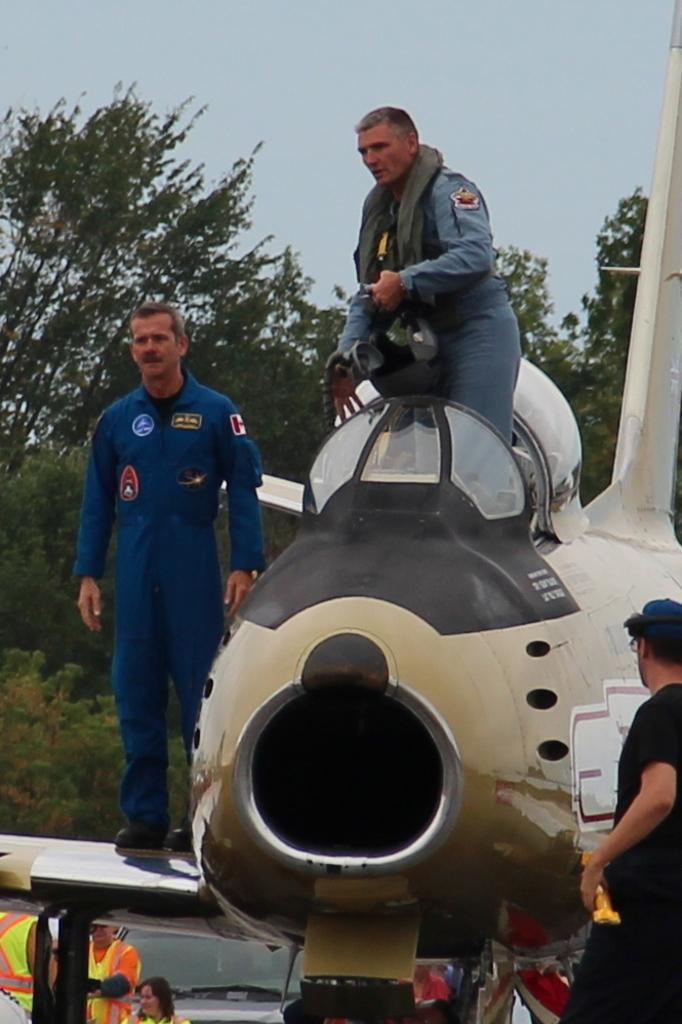What is the main subject of the image? The main subject of the image is an airplane. What are the people in the image doing? The people are standing on the airplane. What can be seen in the background of the image? There is a car, people, and trees visible in the background of the image. What type of sense can be seen in the image? There is no sense present in the image; it features an airplane with people standing on it and a background with a car, people, and trees. Can you tell me how many times the rake is used in the image? There is no rake present in the image. 